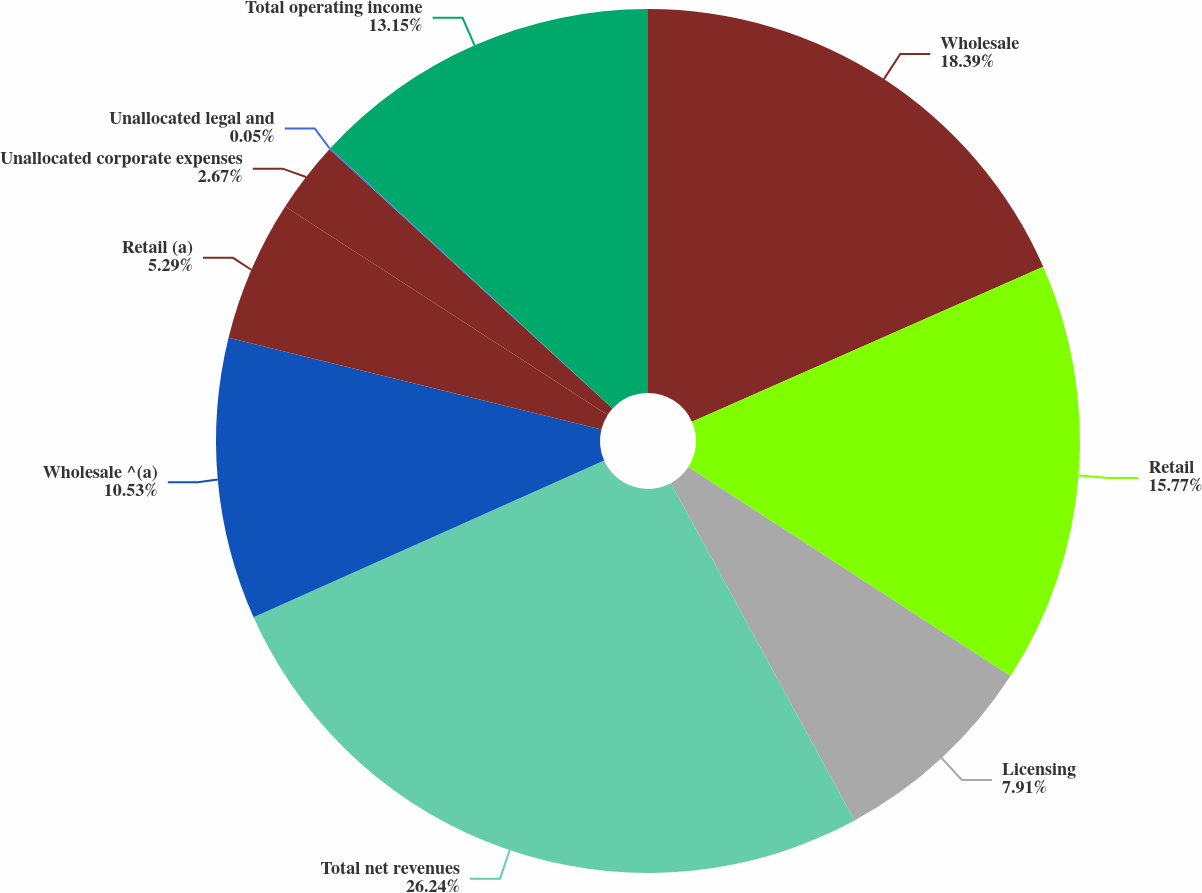Convert chart. <chart><loc_0><loc_0><loc_500><loc_500><pie_chart><fcel>Wholesale<fcel>Retail<fcel>Licensing<fcel>Total net revenues<fcel>Wholesale ^(a)<fcel>Retail (a)<fcel>Unallocated corporate expenses<fcel>Unallocated legal and<fcel>Total operating income<nl><fcel>18.39%<fcel>15.77%<fcel>7.91%<fcel>26.25%<fcel>10.53%<fcel>5.29%<fcel>2.67%<fcel>0.05%<fcel>13.15%<nl></chart> 